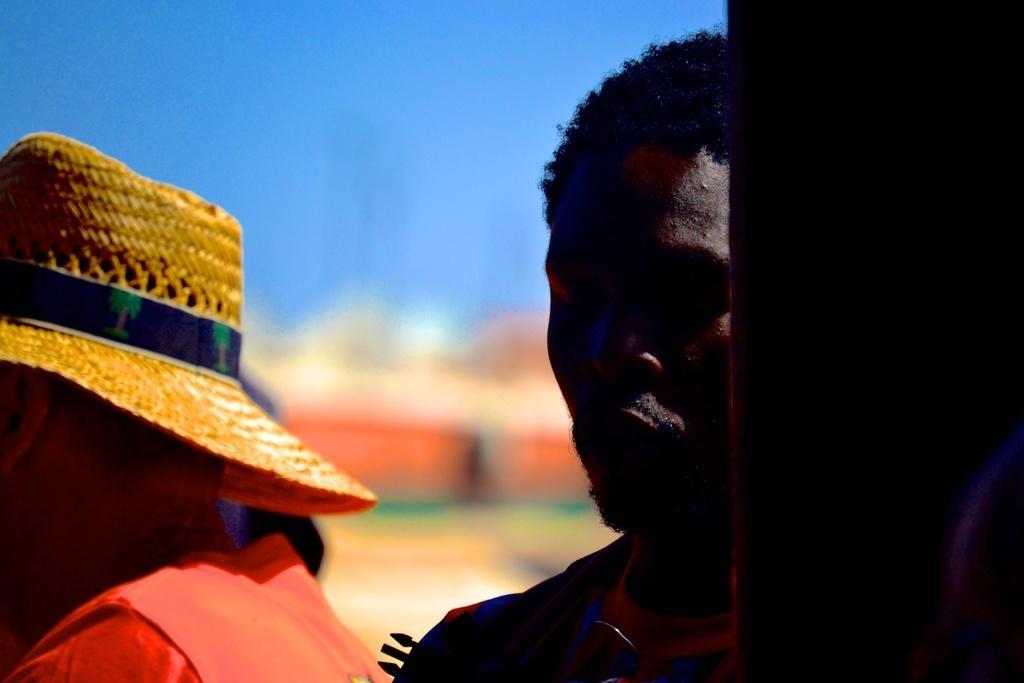Please provide a concise description of this image. In this image there are two people, one of them is wearing a hat, behind them the image is blurred. 